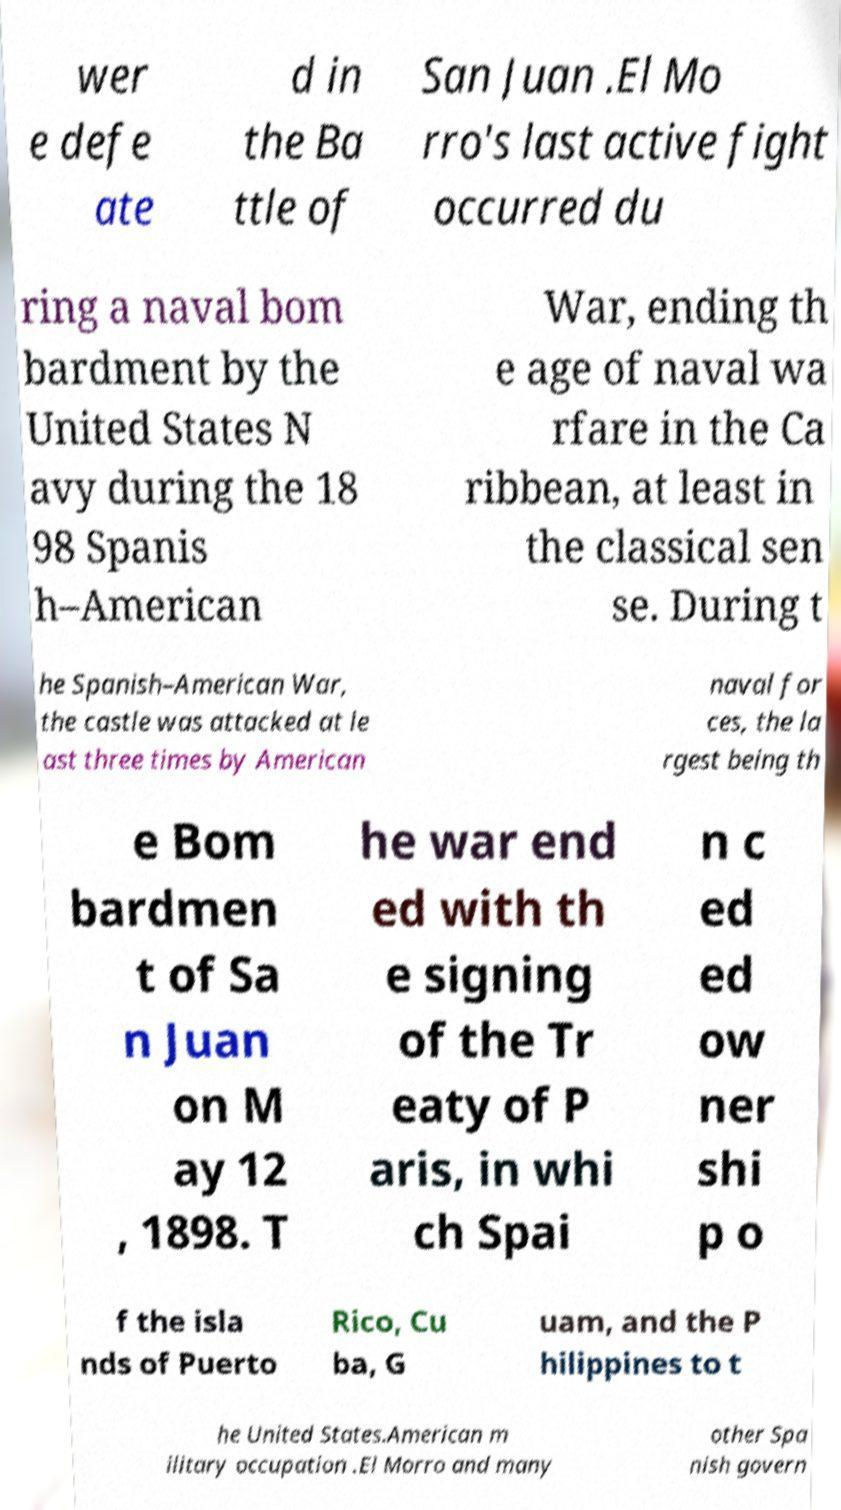Can you accurately transcribe the text from the provided image for me? wer e defe ate d in the Ba ttle of San Juan .El Mo rro's last active fight occurred du ring a naval bom bardment by the United States N avy during the 18 98 Spanis h–American War, ending th e age of naval wa rfare in the Ca ribbean, at least in the classical sen se. During t he Spanish–American War, the castle was attacked at le ast three times by American naval for ces, the la rgest being th e Bom bardmen t of Sa n Juan on M ay 12 , 1898. T he war end ed with th e signing of the Tr eaty of P aris, in whi ch Spai n c ed ed ow ner shi p o f the isla nds of Puerto Rico, Cu ba, G uam, and the P hilippines to t he United States.American m ilitary occupation .El Morro and many other Spa nish govern 